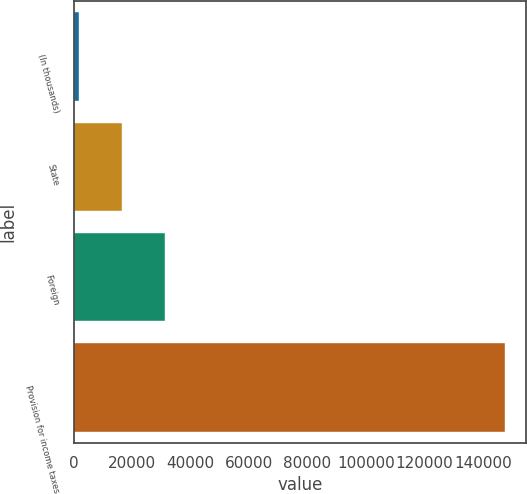<chart> <loc_0><loc_0><loc_500><loc_500><bar_chart><fcel>(In thousands)<fcel>State<fcel>Foreign<fcel>Provision for income taxes<nl><fcel>2013<fcel>16558.9<fcel>31104.8<fcel>147472<nl></chart> 